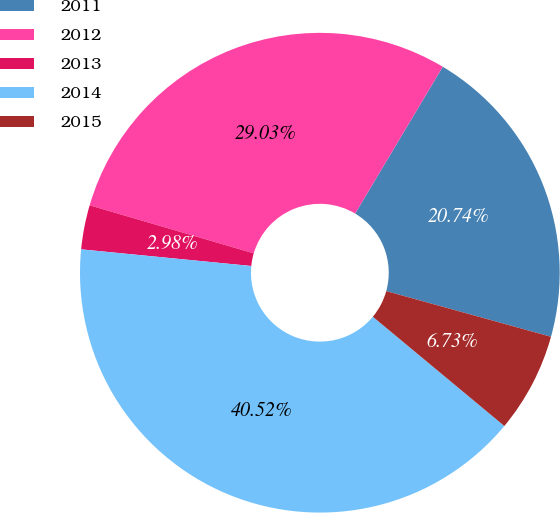Convert chart. <chart><loc_0><loc_0><loc_500><loc_500><pie_chart><fcel>2011<fcel>2012<fcel>2013<fcel>2014<fcel>2015<nl><fcel>20.74%<fcel>29.03%<fcel>2.98%<fcel>40.52%<fcel>6.73%<nl></chart> 